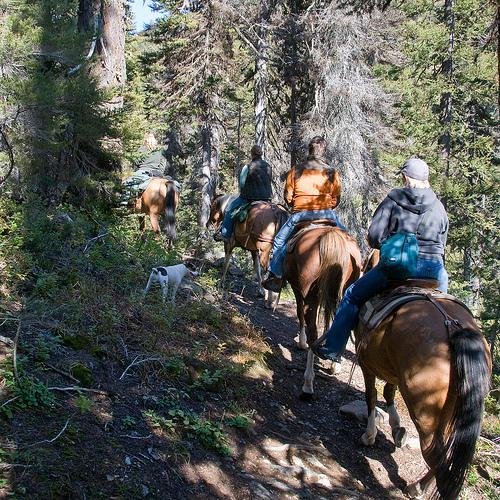Question: what are the people doing?
Choices:
A. Riding motorcycles.
B. Riding donkeys.
C. Riding camels.
D. Riding horses.
Answer with the letter. Answer: D Question: how many animals are pictured?
Choices:
A. 5.
B. 2.
C. 3.
D. 1.
Answer with the letter. Answer: A Question: what is surrounding the riders?
Choices:
A. Bushes.
B. Trees.
C. Flowers.
D. Grass.
Answer with the letter. Answer: B Question: what color is the dog?
Choices:
A. Grey.
B. White.
C. Black.
D. White with a few dark patches.
Answer with the letter. Answer: D Question: how many horseback riders are pictured?
Choices:
A. 2.
B. 4.
C. 3.
D. 9.
Answer with the letter. Answer: B Question: where are the riders?
Choices:
A. In a forest.
B. By the ocean.
C. By the lake.
D. By the trees.
Answer with the letter. Answer: A 